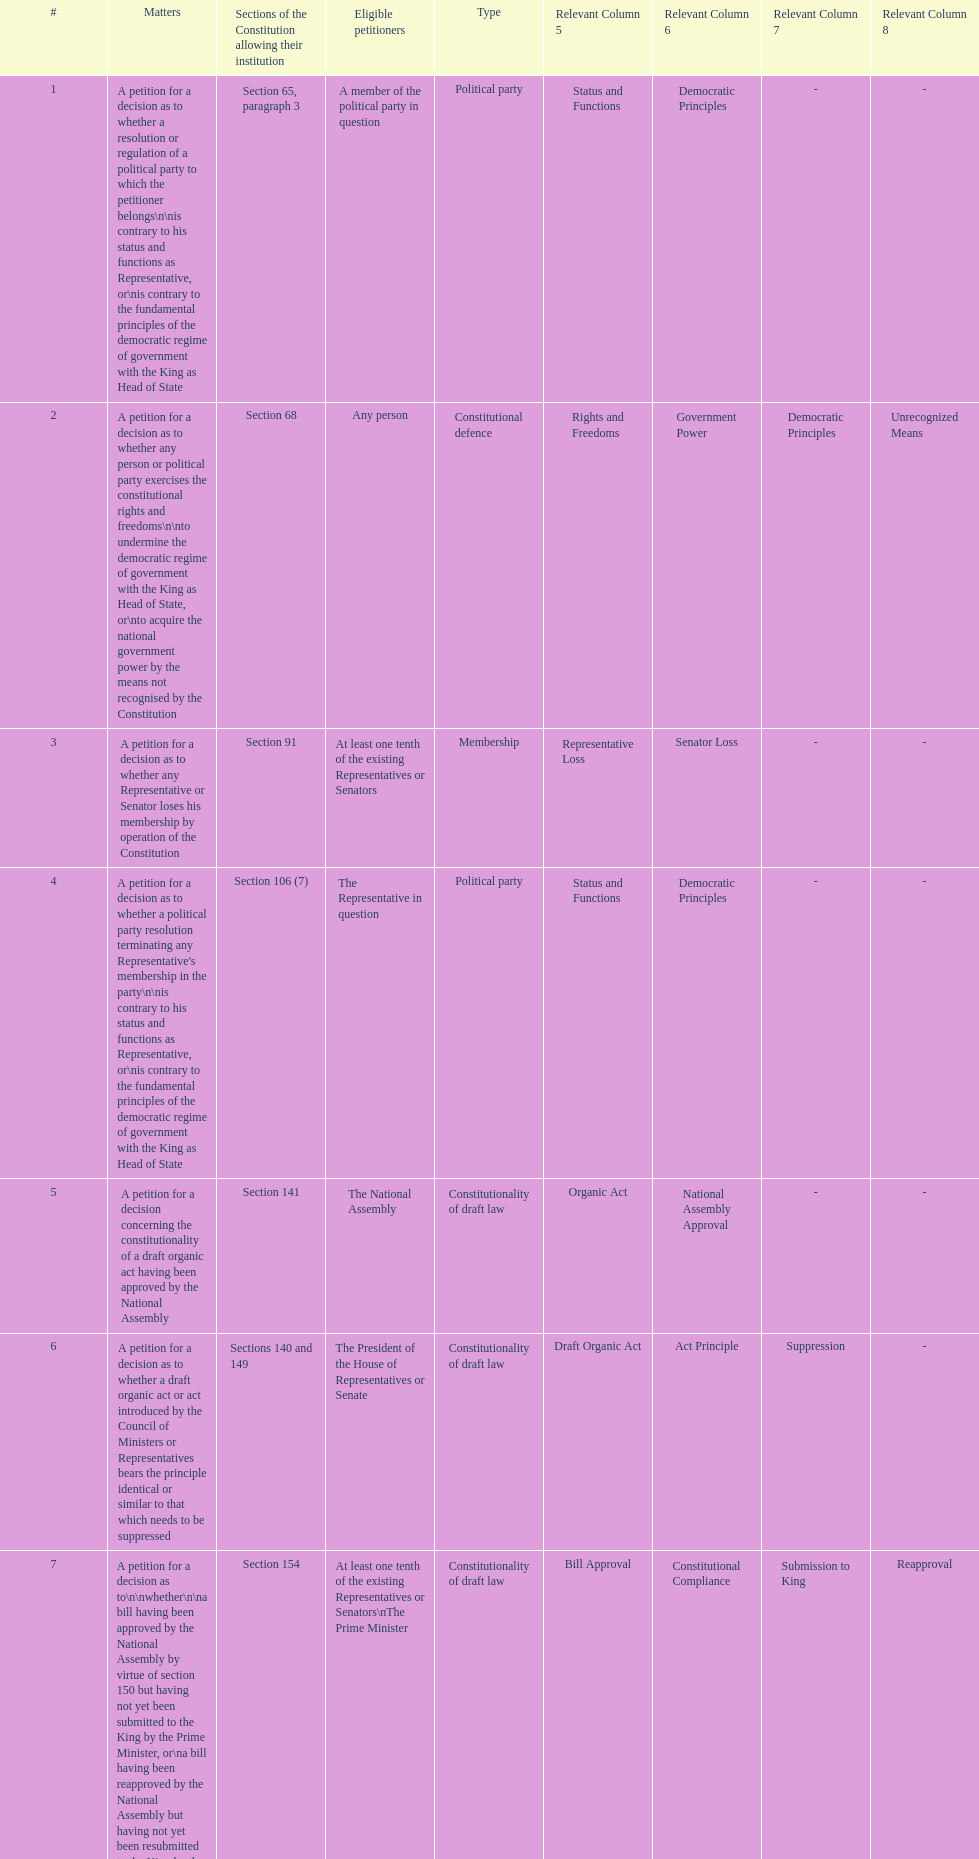Any person can petition matters 2 and 17. true or false? True. 